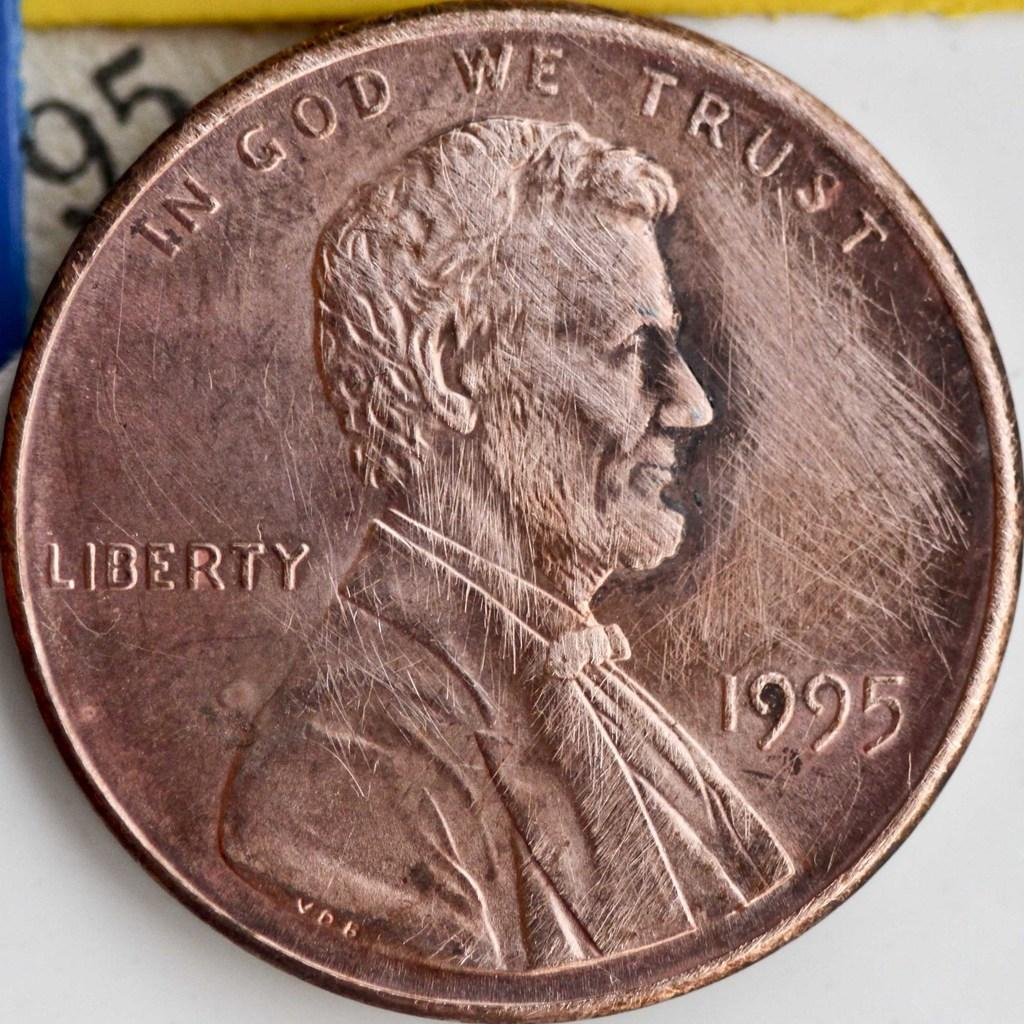Provide a one-sentence caption for the provided image. In God we trust written on a brown penny. 